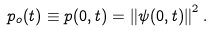<formula> <loc_0><loc_0><loc_500><loc_500>p _ { o } ( t ) \equiv p ( 0 , t ) = \left \| \psi ( 0 , t ) \right \| ^ { 2 } .</formula> 